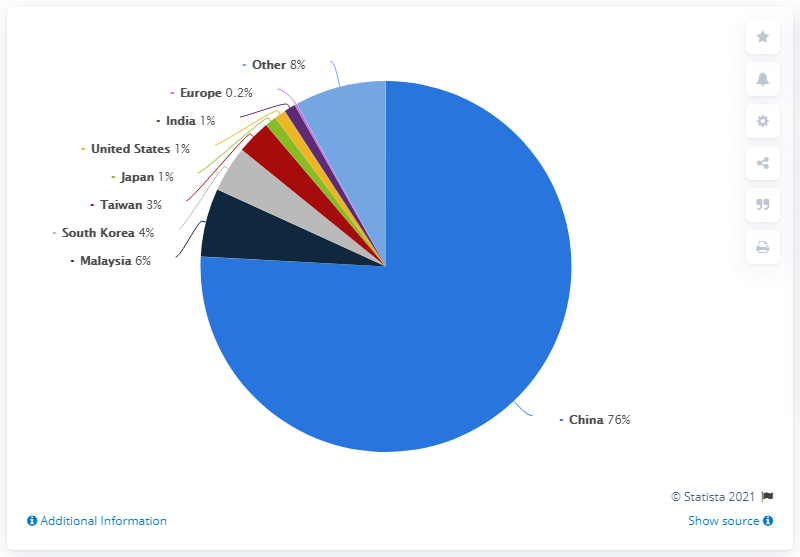Highlight a few significant elements in this photo. The country that contributes the most to production is China. According to the data, only two countries contribute over 4% towards the production. 